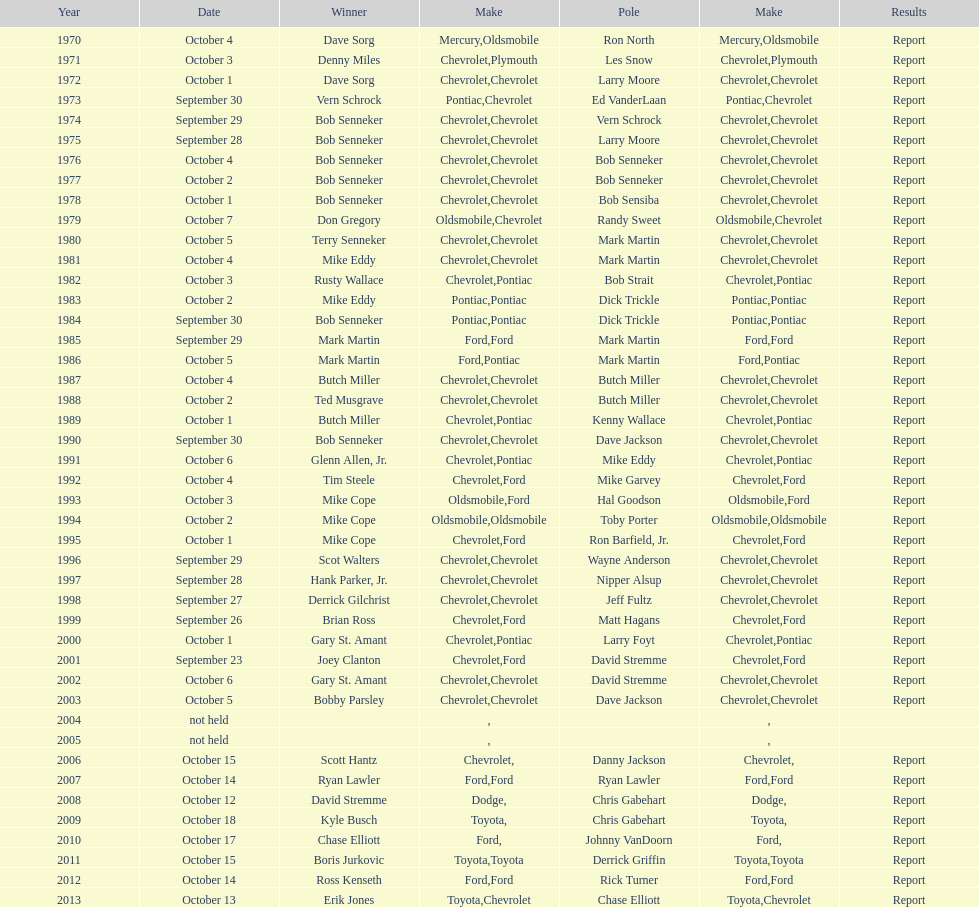Which brand was utilized the least? Mercury. 